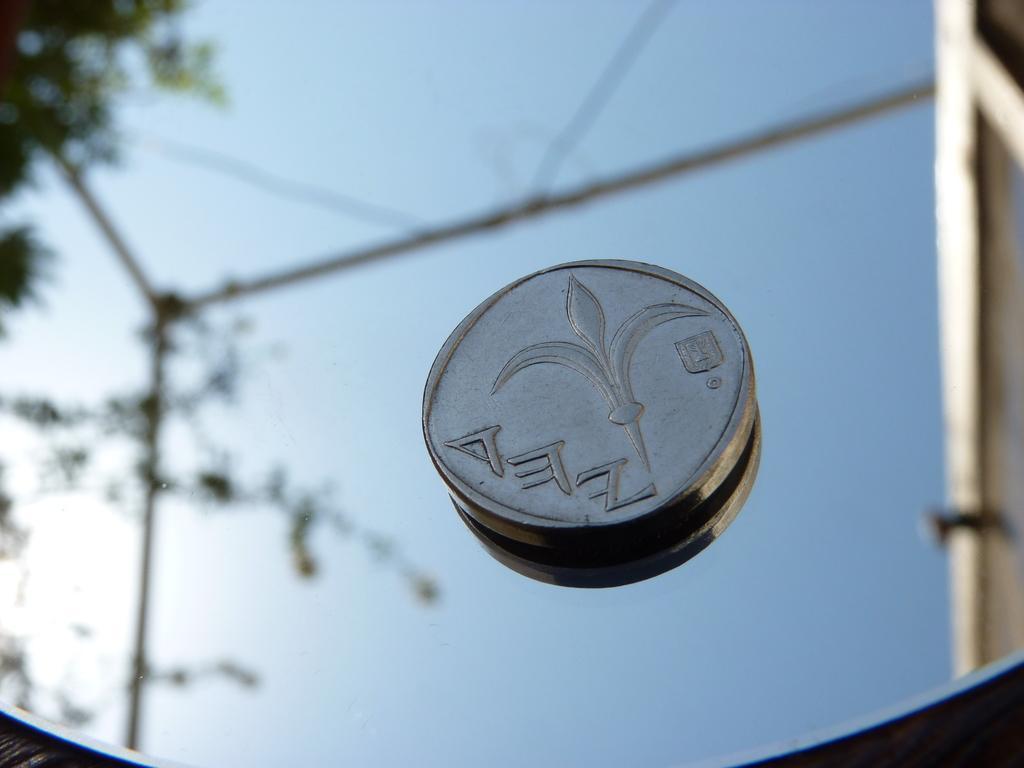Describe this image in one or two sentences. In this image we can see a coin on a mirror. There is reflection of the sky, tree and poles in the mirror.   